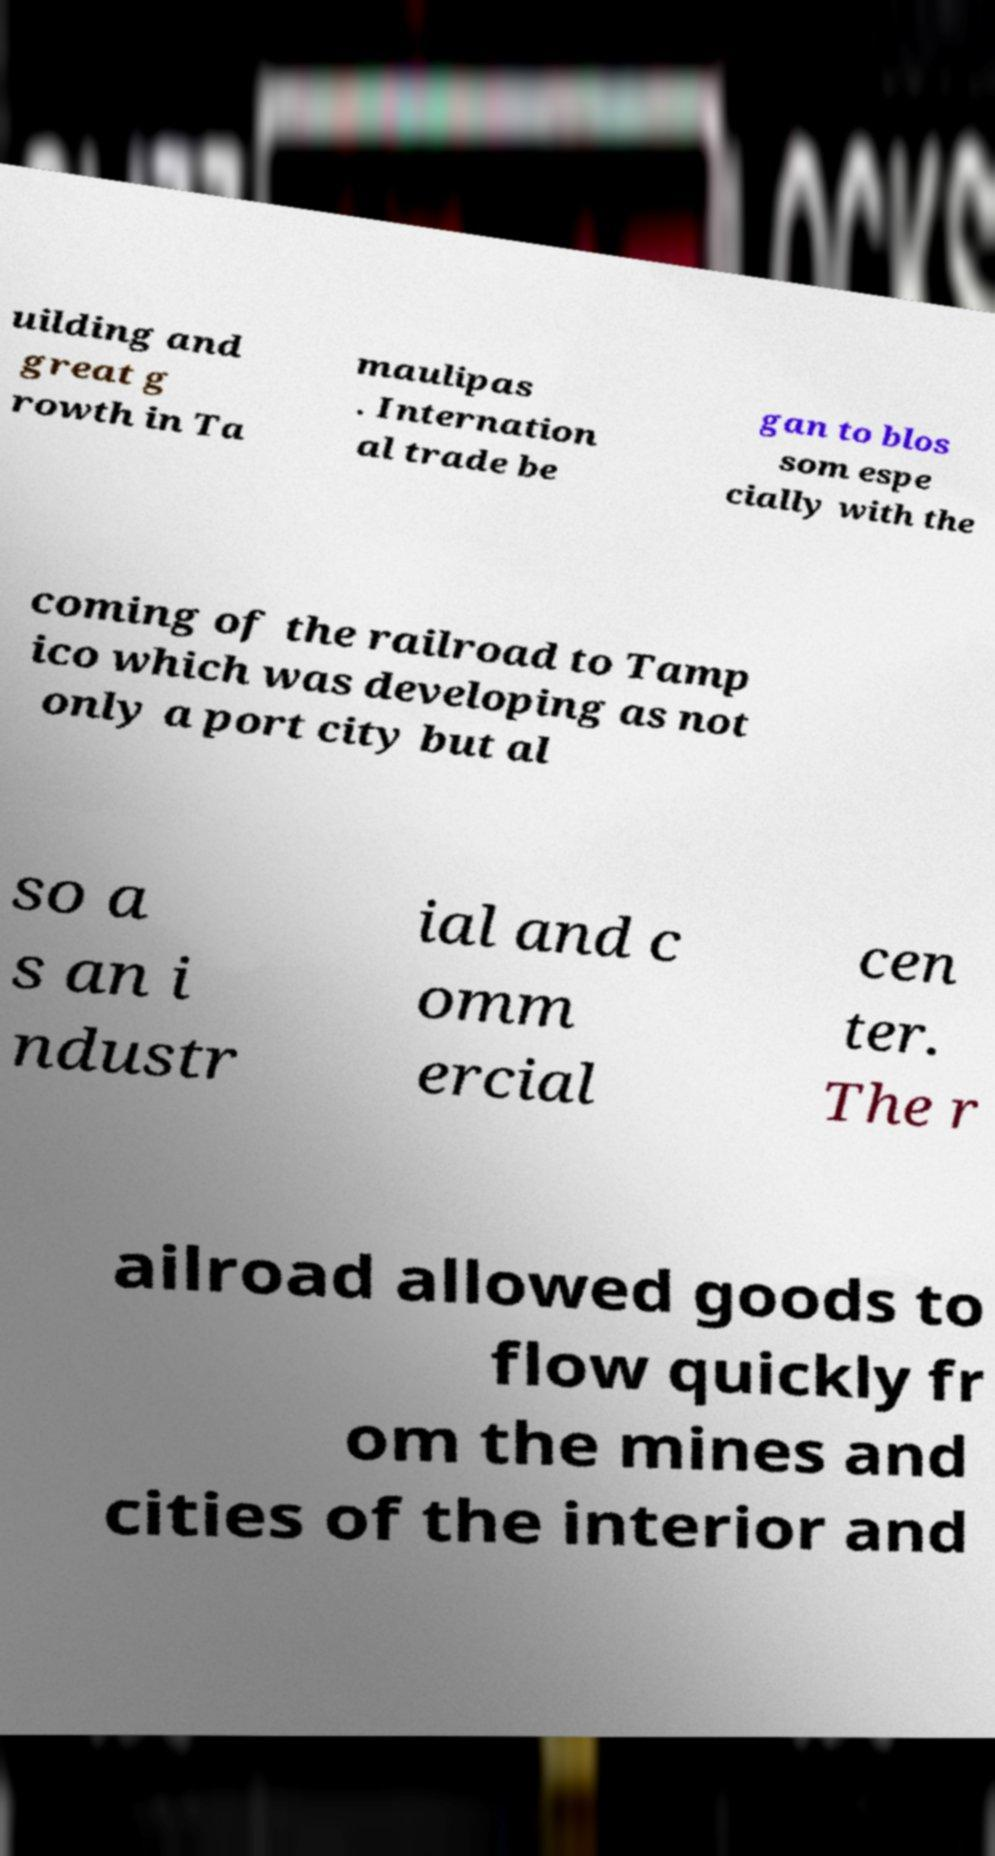For documentation purposes, I need the text within this image transcribed. Could you provide that? uilding and great g rowth in Ta maulipas . Internation al trade be gan to blos som espe cially with the coming of the railroad to Tamp ico which was developing as not only a port city but al so a s an i ndustr ial and c omm ercial cen ter. The r ailroad allowed goods to flow quickly fr om the mines and cities of the interior and 